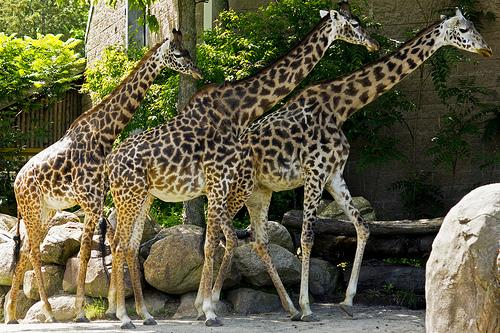Mention the main focal point of the image and any secondary details. Three giraffes in tandem at a zoo are the main focus, with a brown brick wall, green plants, and sunlight on the top of trees as secondary elements. Describe the primary subject of the image and the environment they inhabit. Three giraffes in a line are the main subjects of the image, situated in a zoo environment with greenery, a wall, and boulders. Provide a brief overview of the image focusing on the main subjects and their surroundings. The image features three giraffes at a zoo with a wall, trees, boulders, and plants forming the surrounding environment. Describe the image focusing on the subjects and their physical appearance. The image shows three giraffes with brown spots and white legs, with twelve legs visible and their heads adorned with manes. Mention the positions, physical features, and colors of the objects present in the image. The three giraffes are positioned in a line with several brown spots, long tails, and black hooves, while a brown brick wall, green plants, and sunlight on trees make up the background. Describe the scene in the image with an emphasis on the giraffes. Several giraffes stand in a line at a zoo, their brown and white heads and legs providing contrast against the background featuring a brown brick wall and green plants. Narrate the setting and environment of the image. The image showcases a zoo setting with three giraffes in a line, surrounded by boulders, green plants, and a brown brick wall in the background. Mention the number of primary subjects in the image and their coordinating elements. The image contains three giraffes at a zoo, along with a brown brick wall, green plants, and sunlight on the trees in the backdrop. In the image, describe the positions of the giraffes and any noticeable features. Three giraffes in tandem stand aligned in a zoo, showcasing brown spots, white legs, long tails, and black hooves and eyes. List the main subjects in the image and any additional elements that contribute to the scene. The image contains three giraffes, a brown brick wall, green plants, and sunlight on the trees in the background, forming a cohesive zoo scene. 